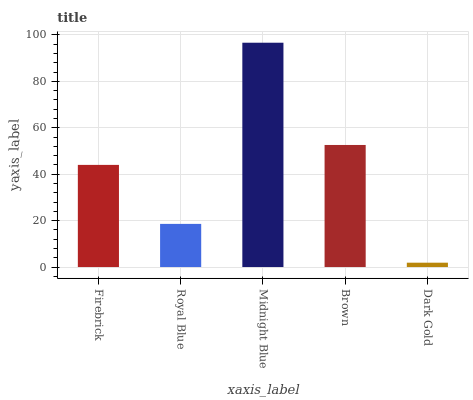Is Dark Gold the minimum?
Answer yes or no. Yes. Is Midnight Blue the maximum?
Answer yes or no. Yes. Is Royal Blue the minimum?
Answer yes or no. No. Is Royal Blue the maximum?
Answer yes or no. No. Is Firebrick greater than Royal Blue?
Answer yes or no. Yes. Is Royal Blue less than Firebrick?
Answer yes or no. Yes. Is Royal Blue greater than Firebrick?
Answer yes or no. No. Is Firebrick less than Royal Blue?
Answer yes or no. No. Is Firebrick the high median?
Answer yes or no. Yes. Is Firebrick the low median?
Answer yes or no. Yes. Is Royal Blue the high median?
Answer yes or no. No. Is Dark Gold the low median?
Answer yes or no. No. 